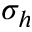Convert formula to latex. <formula><loc_0><loc_0><loc_500><loc_500>\sigma _ { h }</formula> 